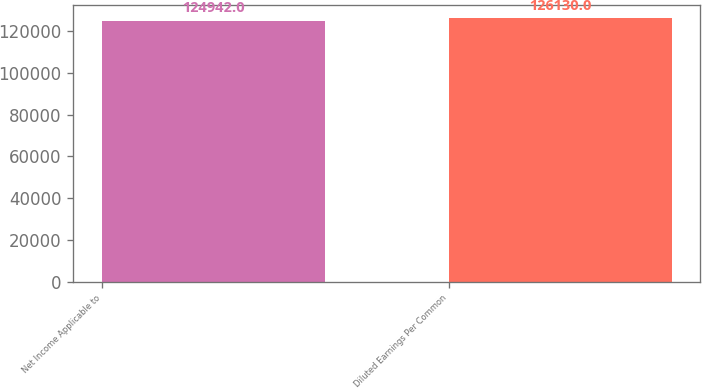<chart> <loc_0><loc_0><loc_500><loc_500><bar_chart><fcel>Net Income Applicable to<fcel>Diluted Earnings Per Common<nl><fcel>124942<fcel>126130<nl></chart> 